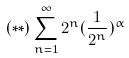Convert formula to latex. <formula><loc_0><loc_0><loc_500><loc_500>( * * ) \sum _ { n = 1 } ^ { \infty } 2 ^ { n } ( \frac { 1 } { 2 ^ { n } } ) ^ { \alpha }</formula> 